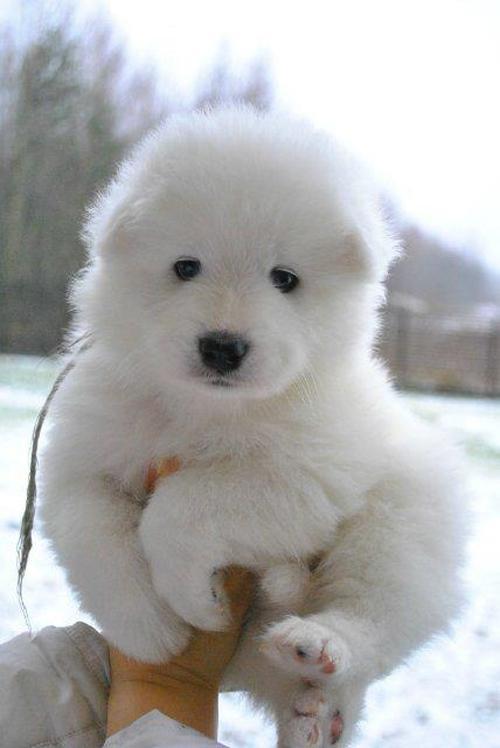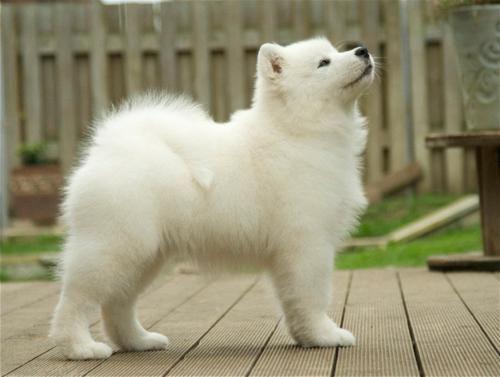The first image is the image on the left, the second image is the image on the right. For the images shown, is this caption "One image contains multiple white dog figures, and the other image shows one white dog held up by a human arm." true? Answer yes or no. No. The first image is the image on the left, the second image is the image on the right. Assess this claim about the two images: "there is grass visible behind a white dog.". Correct or not? Answer yes or no. Yes. 